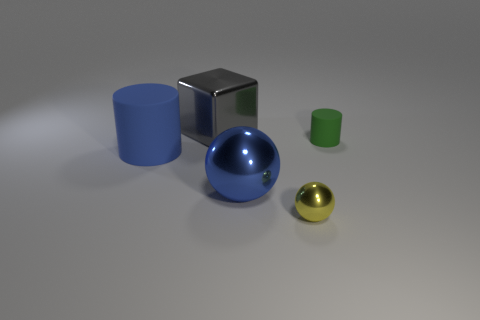There is a metal block; is it the same size as the matte thing that is right of the big gray object?
Make the answer very short. No. Is the size of the blue thing that is on the right side of the gray shiny cube the same as the tiny rubber cylinder?
Ensure brevity in your answer.  No. How many other objects are there of the same material as the big blue cylinder?
Keep it short and to the point. 1. Are there the same number of gray shiny blocks that are to the right of the big gray shiny thing and yellow metal spheres that are left of the tiny metal object?
Provide a short and direct response. Yes. There is a tiny object that is behind the large blue thing on the right side of the large object behind the blue cylinder; what color is it?
Provide a short and direct response. Green. What shape is the tiny object that is on the left side of the green matte object?
Your response must be concise. Sphere. What shape is the blue thing that is the same material as the tiny yellow thing?
Your answer should be compact. Sphere. Is there anything else that has the same shape as the gray shiny thing?
Offer a very short reply. No. There is a tiny yellow metal sphere; how many large blue rubber objects are in front of it?
Make the answer very short. 0. Are there an equal number of large blue cylinders to the right of the blue rubber cylinder and big blue matte cubes?
Provide a short and direct response. Yes. 